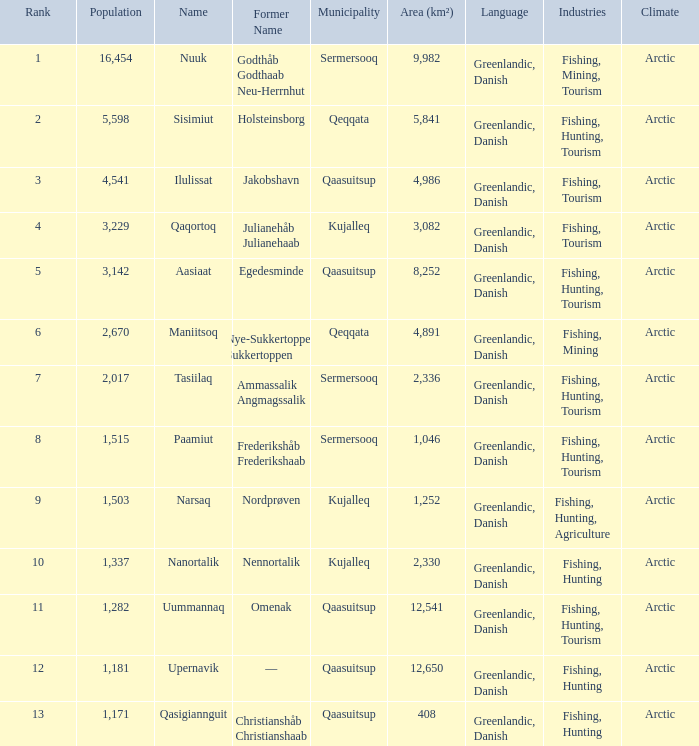Who has a former name of nordprøven? Narsaq. 